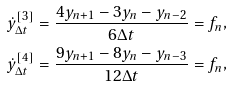Convert formula to latex. <formula><loc_0><loc_0><loc_500><loc_500>\dot { y } _ { \Delta t } ^ { [ 3 ] } = \frac { 4 y _ { n + 1 } - 3 y _ { n } - y _ { n - 2 } } { 6 \Delta t } = f _ { n } , \\ \dot { y } _ { \Delta t } ^ { [ 4 ] } = \frac { 9 y _ { n + 1 } - 8 y _ { n } - y _ { n - 3 } } { 1 2 \Delta t } = f _ { n } ,</formula> 